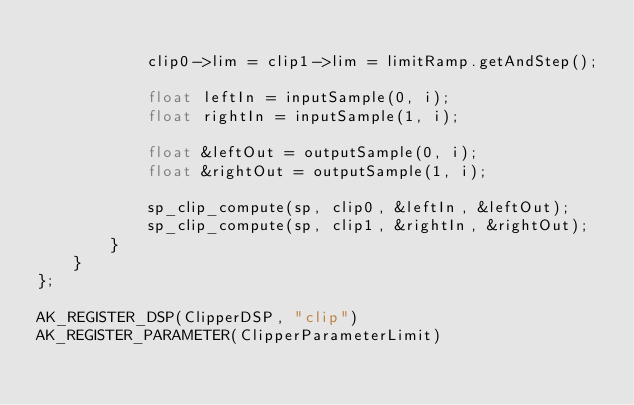Convert code to text. <code><loc_0><loc_0><loc_500><loc_500><_ObjectiveC_>
            clip0->lim = clip1->lim = limitRamp.getAndStep();

            float leftIn = inputSample(0, i);
            float rightIn = inputSample(1, i);

            float &leftOut = outputSample(0, i);
            float &rightOut = outputSample(1, i);

            sp_clip_compute(sp, clip0, &leftIn, &leftOut);
            sp_clip_compute(sp, clip1, &rightIn, &rightOut);
        }
    }
};

AK_REGISTER_DSP(ClipperDSP, "clip")
AK_REGISTER_PARAMETER(ClipperParameterLimit)
</code> 